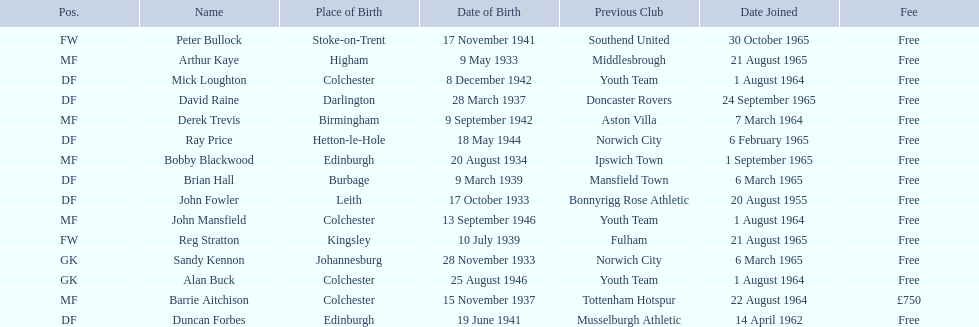When did alan buck join the colchester united f.c. in 1965-66? 1 August 1964. When did the last player to join? Peter Bullock. What date did the first player join? 20 August 1955. 